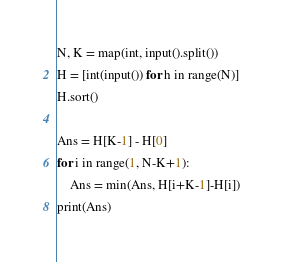<code> <loc_0><loc_0><loc_500><loc_500><_Python_>N, K = map(int, input().split())
H = [int(input()) for h in range(N)]
H.sort()

Ans = H[K-1] - H[0]
for i in range(1, N-K+1):
    Ans = min(Ans, H[i+K-1]-H[i])
print(Ans)
</code> 